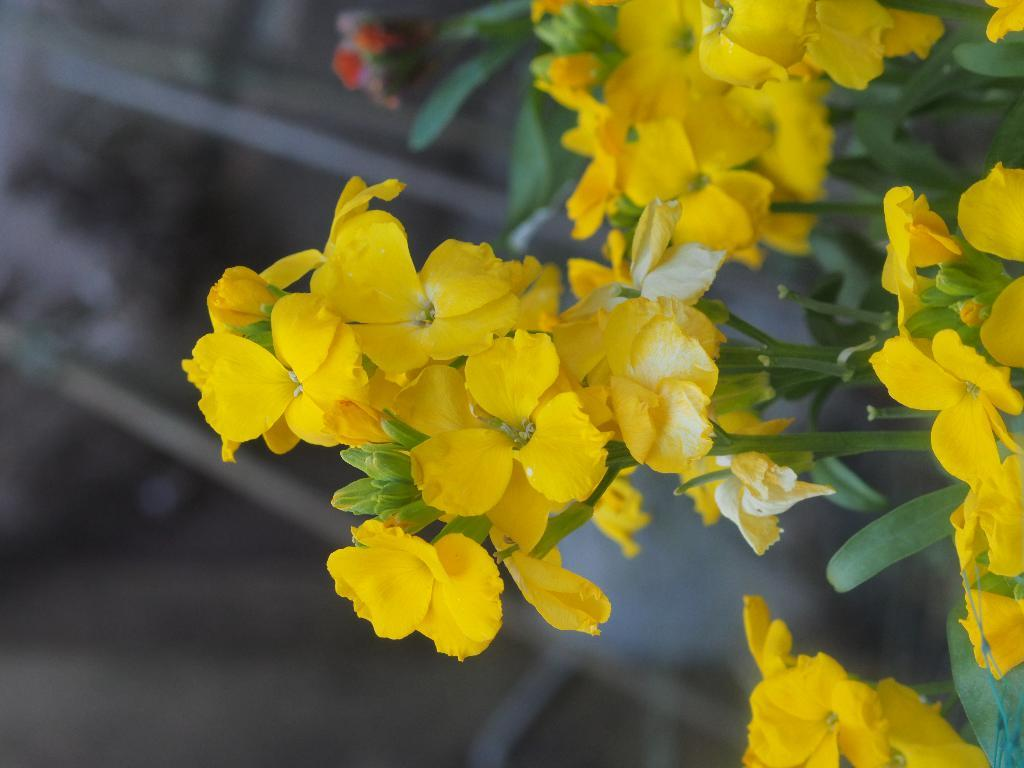What color are the flowers in the image? The flowers in the image are yellow. What other parts of the plant can be seen in the image besides the flowers? The flowers have leaves in the image. How are the flowers attached to the plant? The flowers are on a stem in the image. What type of quill can be seen in the image? There is no quill present in the image; it features yellow flowers with leaves and stems. How many teeth can be seen in the image? There are no teeth present in the image; it features yellow flowers with leaves and stems. 